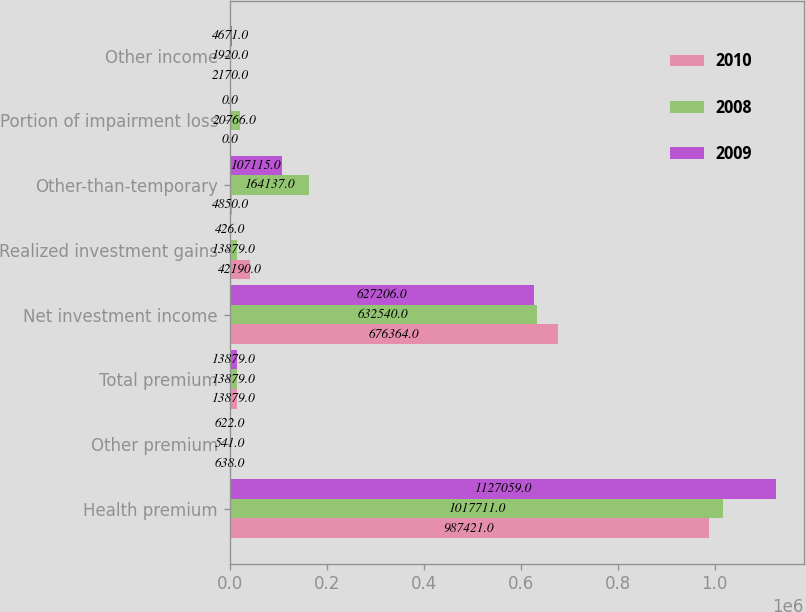Convert chart. <chart><loc_0><loc_0><loc_500><loc_500><stacked_bar_chart><ecel><fcel>Health premium<fcel>Other premium<fcel>Total premium<fcel>Net investment income<fcel>Realized investment gains<fcel>Other-than-temporary<fcel>Portion of impairment loss<fcel>Other income<nl><fcel>2010<fcel>987421<fcel>638<fcel>13879<fcel>676364<fcel>42190<fcel>4850<fcel>0<fcel>2170<nl><fcel>2008<fcel>1.01771e+06<fcel>541<fcel>13879<fcel>632540<fcel>13879<fcel>164137<fcel>20766<fcel>1920<nl><fcel>2009<fcel>1.12706e+06<fcel>622<fcel>13879<fcel>627206<fcel>426<fcel>107115<fcel>0<fcel>4671<nl></chart> 